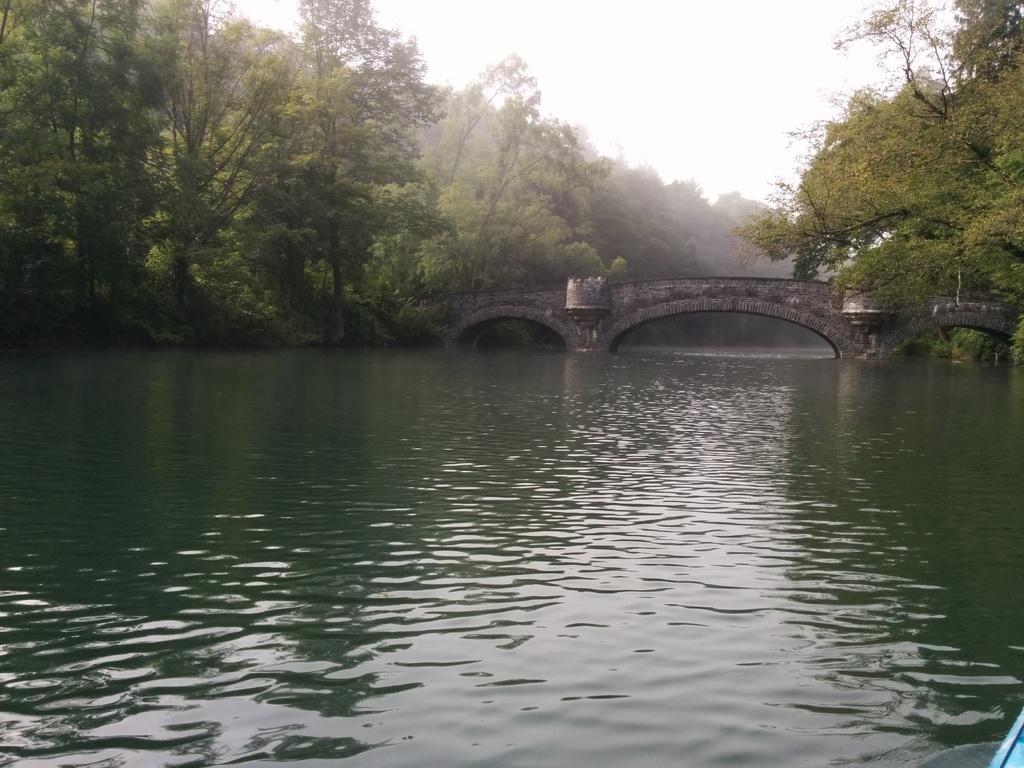Please provide a concise description of this image. In this picture we can see a river flowing under a tunnel of a bridge surrounded by trees. 